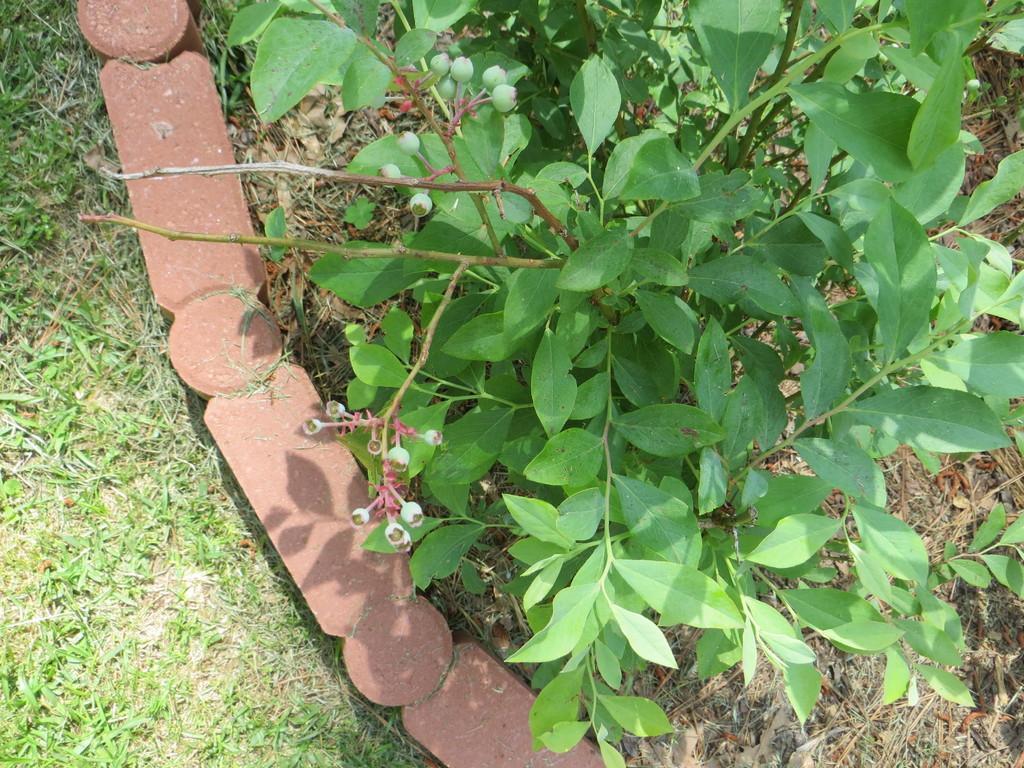In one or two sentences, can you explain what this image depicts? In this image I can see a plant on the grass ground. I can also see few brown colour stones on the left side. 